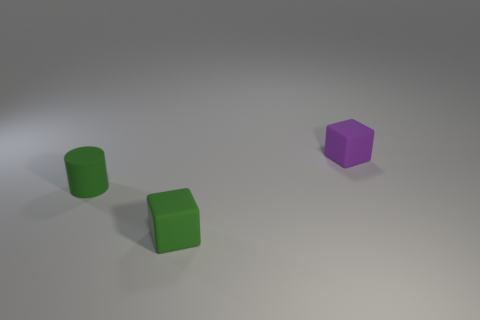How many matte objects are cylinders or green spheres?
Your answer should be compact. 1. What color is the other matte thing that is the same shape as the tiny purple thing?
Provide a short and direct response. Green. Are any yellow metallic cubes visible?
Offer a terse response. No. Is the material of the small block behind the green cylinder the same as the block that is on the left side of the small purple rubber block?
Offer a terse response. Yes. What shape is the thing that is the same color as the cylinder?
Keep it short and to the point. Cube. How many things are either blocks in front of the tiny purple thing or small rubber things that are right of the tiny green rubber block?
Keep it short and to the point. 2. There is a rubber thing to the left of the green cube; is it the same color as the rubber block in front of the small rubber cylinder?
Give a very brief answer. Yes. There is a tiny thing that is both to the left of the tiny purple object and behind the green matte cube; what shape is it?
Your response must be concise. Cylinder. There is a cylinder that is the same size as the purple matte object; what is its color?
Ensure brevity in your answer.  Green. Are there any other tiny cylinders that have the same color as the tiny matte cylinder?
Provide a short and direct response. No. 